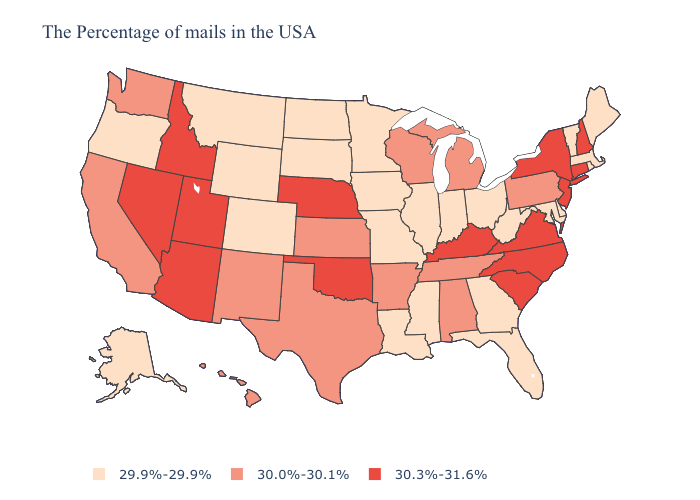Among the states that border Delaware , does Maryland have the highest value?
Quick response, please. No. What is the lowest value in states that border Idaho?
Give a very brief answer. 29.9%-29.9%. What is the value of Arizona?
Keep it brief. 30.3%-31.6%. Which states have the highest value in the USA?
Write a very short answer. New Hampshire, Connecticut, New York, New Jersey, Virginia, North Carolina, South Carolina, Kentucky, Nebraska, Oklahoma, Utah, Arizona, Idaho, Nevada. Which states have the lowest value in the West?
Quick response, please. Wyoming, Colorado, Montana, Oregon, Alaska. Which states have the lowest value in the Northeast?
Keep it brief. Maine, Massachusetts, Rhode Island, Vermont. Among the states that border Montana , which have the lowest value?
Answer briefly. South Dakota, North Dakota, Wyoming. Which states have the lowest value in the USA?
Be succinct. Maine, Massachusetts, Rhode Island, Vermont, Delaware, Maryland, West Virginia, Ohio, Florida, Georgia, Indiana, Illinois, Mississippi, Louisiana, Missouri, Minnesota, Iowa, South Dakota, North Dakota, Wyoming, Colorado, Montana, Oregon, Alaska. Among the states that border Florida , which have the lowest value?
Write a very short answer. Georgia. What is the lowest value in the West?
Concise answer only. 29.9%-29.9%. What is the value of West Virginia?
Concise answer only. 29.9%-29.9%. What is the value of Ohio?
Be succinct. 29.9%-29.9%. Is the legend a continuous bar?
Give a very brief answer. No. What is the lowest value in the Northeast?
Write a very short answer. 29.9%-29.9%. 